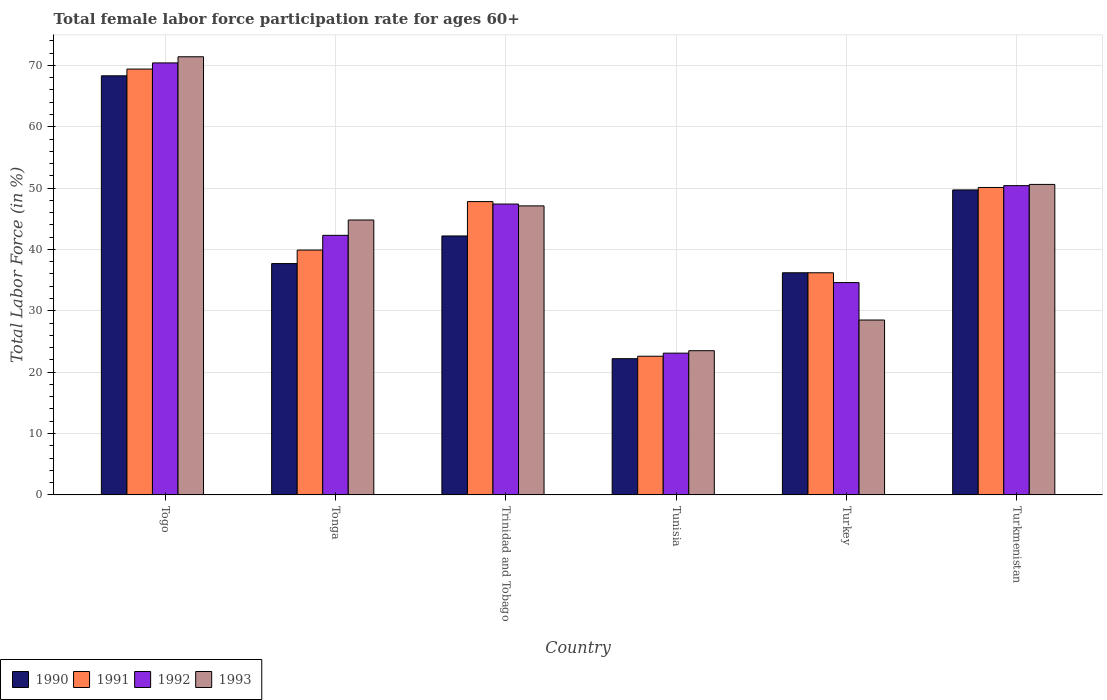How many different coloured bars are there?
Your response must be concise. 4. Are the number of bars per tick equal to the number of legend labels?
Give a very brief answer. Yes. How many bars are there on the 3rd tick from the right?
Give a very brief answer. 4. What is the label of the 3rd group of bars from the left?
Provide a short and direct response. Trinidad and Tobago. In how many cases, is the number of bars for a given country not equal to the number of legend labels?
Offer a terse response. 0. Across all countries, what is the maximum female labor force participation rate in 1990?
Offer a terse response. 68.3. Across all countries, what is the minimum female labor force participation rate in 1992?
Offer a very short reply. 23.1. In which country was the female labor force participation rate in 1991 maximum?
Ensure brevity in your answer.  Togo. In which country was the female labor force participation rate in 1990 minimum?
Keep it short and to the point. Tunisia. What is the total female labor force participation rate in 1990 in the graph?
Your response must be concise. 256.3. What is the difference between the female labor force participation rate in 1993 in Trinidad and Tobago and that in Turkey?
Keep it short and to the point. 18.6. What is the difference between the female labor force participation rate in 1990 in Turkmenistan and the female labor force participation rate in 1991 in Togo?
Your answer should be very brief. -19.7. What is the average female labor force participation rate in 1992 per country?
Your answer should be compact. 44.7. What is the difference between the female labor force participation rate of/in 1991 and female labor force participation rate of/in 1990 in Turkmenistan?
Your response must be concise. 0.4. What is the ratio of the female labor force participation rate in 1992 in Tonga to that in Turkmenistan?
Your answer should be very brief. 0.84. Is the female labor force participation rate in 1990 in Trinidad and Tobago less than that in Tunisia?
Keep it short and to the point. No. What is the difference between the highest and the lowest female labor force participation rate in 1992?
Your answer should be very brief. 47.3. In how many countries, is the female labor force participation rate in 1993 greater than the average female labor force participation rate in 1993 taken over all countries?
Your answer should be compact. 4. What does the 1st bar from the left in Tunisia represents?
Give a very brief answer. 1990. Is it the case that in every country, the sum of the female labor force participation rate in 1991 and female labor force participation rate in 1990 is greater than the female labor force participation rate in 1993?
Your answer should be very brief. Yes. Are all the bars in the graph horizontal?
Provide a succinct answer. No. How many countries are there in the graph?
Give a very brief answer. 6. Does the graph contain any zero values?
Keep it short and to the point. No. How are the legend labels stacked?
Provide a succinct answer. Horizontal. What is the title of the graph?
Give a very brief answer. Total female labor force participation rate for ages 60+. Does "1976" appear as one of the legend labels in the graph?
Keep it short and to the point. No. What is the label or title of the X-axis?
Offer a very short reply. Country. What is the Total Labor Force (in %) in 1990 in Togo?
Ensure brevity in your answer.  68.3. What is the Total Labor Force (in %) in 1991 in Togo?
Your answer should be compact. 69.4. What is the Total Labor Force (in %) of 1992 in Togo?
Your answer should be compact. 70.4. What is the Total Labor Force (in %) of 1993 in Togo?
Make the answer very short. 71.4. What is the Total Labor Force (in %) in 1990 in Tonga?
Make the answer very short. 37.7. What is the Total Labor Force (in %) in 1991 in Tonga?
Provide a short and direct response. 39.9. What is the Total Labor Force (in %) in 1992 in Tonga?
Offer a very short reply. 42.3. What is the Total Labor Force (in %) of 1993 in Tonga?
Offer a very short reply. 44.8. What is the Total Labor Force (in %) of 1990 in Trinidad and Tobago?
Give a very brief answer. 42.2. What is the Total Labor Force (in %) in 1991 in Trinidad and Tobago?
Offer a very short reply. 47.8. What is the Total Labor Force (in %) in 1992 in Trinidad and Tobago?
Give a very brief answer. 47.4. What is the Total Labor Force (in %) of 1993 in Trinidad and Tobago?
Your response must be concise. 47.1. What is the Total Labor Force (in %) of 1990 in Tunisia?
Give a very brief answer. 22.2. What is the Total Labor Force (in %) of 1991 in Tunisia?
Your answer should be very brief. 22.6. What is the Total Labor Force (in %) of 1992 in Tunisia?
Offer a terse response. 23.1. What is the Total Labor Force (in %) in 1993 in Tunisia?
Offer a terse response. 23.5. What is the Total Labor Force (in %) of 1990 in Turkey?
Keep it short and to the point. 36.2. What is the Total Labor Force (in %) of 1991 in Turkey?
Provide a short and direct response. 36.2. What is the Total Labor Force (in %) of 1992 in Turkey?
Keep it short and to the point. 34.6. What is the Total Labor Force (in %) of 1990 in Turkmenistan?
Your answer should be compact. 49.7. What is the Total Labor Force (in %) in 1991 in Turkmenistan?
Your answer should be compact. 50.1. What is the Total Labor Force (in %) in 1992 in Turkmenistan?
Your response must be concise. 50.4. What is the Total Labor Force (in %) of 1993 in Turkmenistan?
Offer a terse response. 50.6. Across all countries, what is the maximum Total Labor Force (in %) in 1990?
Make the answer very short. 68.3. Across all countries, what is the maximum Total Labor Force (in %) in 1991?
Your response must be concise. 69.4. Across all countries, what is the maximum Total Labor Force (in %) in 1992?
Provide a succinct answer. 70.4. Across all countries, what is the maximum Total Labor Force (in %) of 1993?
Keep it short and to the point. 71.4. Across all countries, what is the minimum Total Labor Force (in %) of 1990?
Your response must be concise. 22.2. Across all countries, what is the minimum Total Labor Force (in %) of 1991?
Give a very brief answer. 22.6. Across all countries, what is the minimum Total Labor Force (in %) in 1992?
Offer a terse response. 23.1. What is the total Total Labor Force (in %) of 1990 in the graph?
Your response must be concise. 256.3. What is the total Total Labor Force (in %) in 1991 in the graph?
Offer a very short reply. 266. What is the total Total Labor Force (in %) of 1992 in the graph?
Offer a very short reply. 268.2. What is the total Total Labor Force (in %) of 1993 in the graph?
Make the answer very short. 265.9. What is the difference between the Total Labor Force (in %) in 1990 in Togo and that in Tonga?
Offer a terse response. 30.6. What is the difference between the Total Labor Force (in %) in 1991 in Togo and that in Tonga?
Your answer should be very brief. 29.5. What is the difference between the Total Labor Force (in %) in 1992 in Togo and that in Tonga?
Keep it short and to the point. 28.1. What is the difference between the Total Labor Force (in %) in 1993 in Togo and that in Tonga?
Your answer should be compact. 26.6. What is the difference between the Total Labor Force (in %) in 1990 in Togo and that in Trinidad and Tobago?
Give a very brief answer. 26.1. What is the difference between the Total Labor Force (in %) of 1991 in Togo and that in Trinidad and Tobago?
Your answer should be compact. 21.6. What is the difference between the Total Labor Force (in %) of 1993 in Togo and that in Trinidad and Tobago?
Your answer should be very brief. 24.3. What is the difference between the Total Labor Force (in %) of 1990 in Togo and that in Tunisia?
Give a very brief answer. 46.1. What is the difference between the Total Labor Force (in %) in 1991 in Togo and that in Tunisia?
Offer a terse response. 46.8. What is the difference between the Total Labor Force (in %) of 1992 in Togo and that in Tunisia?
Provide a short and direct response. 47.3. What is the difference between the Total Labor Force (in %) in 1993 in Togo and that in Tunisia?
Make the answer very short. 47.9. What is the difference between the Total Labor Force (in %) of 1990 in Togo and that in Turkey?
Offer a terse response. 32.1. What is the difference between the Total Labor Force (in %) in 1991 in Togo and that in Turkey?
Provide a succinct answer. 33.2. What is the difference between the Total Labor Force (in %) of 1992 in Togo and that in Turkey?
Make the answer very short. 35.8. What is the difference between the Total Labor Force (in %) in 1993 in Togo and that in Turkey?
Your answer should be compact. 42.9. What is the difference between the Total Labor Force (in %) in 1991 in Togo and that in Turkmenistan?
Your answer should be very brief. 19.3. What is the difference between the Total Labor Force (in %) of 1993 in Togo and that in Turkmenistan?
Ensure brevity in your answer.  20.8. What is the difference between the Total Labor Force (in %) in 1991 in Tonga and that in Trinidad and Tobago?
Your response must be concise. -7.9. What is the difference between the Total Labor Force (in %) in 1991 in Tonga and that in Tunisia?
Ensure brevity in your answer.  17.3. What is the difference between the Total Labor Force (in %) of 1993 in Tonga and that in Tunisia?
Ensure brevity in your answer.  21.3. What is the difference between the Total Labor Force (in %) in 1990 in Tonga and that in Turkey?
Ensure brevity in your answer.  1.5. What is the difference between the Total Labor Force (in %) of 1991 in Tonga and that in Turkey?
Ensure brevity in your answer.  3.7. What is the difference between the Total Labor Force (in %) in 1993 in Tonga and that in Turkey?
Keep it short and to the point. 16.3. What is the difference between the Total Labor Force (in %) of 1990 in Tonga and that in Turkmenistan?
Your answer should be compact. -12. What is the difference between the Total Labor Force (in %) in 1991 in Tonga and that in Turkmenistan?
Provide a succinct answer. -10.2. What is the difference between the Total Labor Force (in %) of 1991 in Trinidad and Tobago and that in Tunisia?
Provide a succinct answer. 25.2. What is the difference between the Total Labor Force (in %) of 1992 in Trinidad and Tobago and that in Tunisia?
Provide a succinct answer. 24.3. What is the difference between the Total Labor Force (in %) of 1993 in Trinidad and Tobago and that in Tunisia?
Ensure brevity in your answer.  23.6. What is the difference between the Total Labor Force (in %) of 1990 in Trinidad and Tobago and that in Turkey?
Offer a terse response. 6. What is the difference between the Total Labor Force (in %) in 1991 in Trinidad and Tobago and that in Turkey?
Make the answer very short. 11.6. What is the difference between the Total Labor Force (in %) of 1992 in Trinidad and Tobago and that in Turkey?
Your response must be concise. 12.8. What is the difference between the Total Labor Force (in %) in 1991 in Trinidad and Tobago and that in Turkmenistan?
Offer a very short reply. -2.3. What is the difference between the Total Labor Force (in %) of 1991 in Tunisia and that in Turkey?
Make the answer very short. -13.6. What is the difference between the Total Labor Force (in %) of 1993 in Tunisia and that in Turkey?
Provide a short and direct response. -5. What is the difference between the Total Labor Force (in %) of 1990 in Tunisia and that in Turkmenistan?
Provide a short and direct response. -27.5. What is the difference between the Total Labor Force (in %) of 1991 in Tunisia and that in Turkmenistan?
Keep it short and to the point. -27.5. What is the difference between the Total Labor Force (in %) in 1992 in Tunisia and that in Turkmenistan?
Your answer should be compact. -27.3. What is the difference between the Total Labor Force (in %) of 1993 in Tunisia and that in Turkmenistan?
Make the answer very short. -27.1. What is the difference between the Total Labor Force (in %) of 1992 in Turkey and that in Turkmenistan?
Offer a very short reply. -15.8. What is the difference between the Total Labor Force (in %) in 1993 in Turkey and that in Turkmenistan?
Ensure brevity in your answer.  -22.1. What is the difference between the Total Labor Force (in %) of 1990 in Togo and the Total Labor Force (in %) of 1991 in Tonga?
Give a very brief answer. 28.4. What is the difference between the Total Labor Force (in %) in 1990 in Togo and the Total Labor Force (in %) in 1993 in Tonga?
Your answer should be very brief. 23.5. What is the difference between the Total Labor Force (in %) in 1991 in Togo and the Total Labor Force (in %) in 1992 in Tonga?
Give a very brief answer. 27.1. What is the difference between the Total Labor Force (in %) in 1991 in Togo and the Total Labor Force (in %) in 1993 in Tonga?
Keep it short and to the point. 24.6. What is the difference between the Total Labor Force (in %) of 1992 in Togo and the Total Labor Force (in %) of 1993 in Tonga?
Make the answer very short. 25.6. What is the difference between the Total Labor Force (in %) in 1990 in Togo and the Total Labor Force (in %) in 1991 in Trinidad and Tobago?
Provide a short and direct response. 20.5. What is the difference between the Total Labor Force (in %) in 1990 in Togo and the Total Labor Force (in %) in 1992 in Trinidad and Tobago?
Give a very brief answer. 20.9. What is the difference between the Total Labor Force (in %) of 1990 in Togo and the Total Labor Force (in %) of 1993 in Trinidad and Tobago?
Keep it short and to the point. 21.2. What is the difference between the Total Labor Force (in %) of 1991 in Togo and the Total Labor Force (in %) of 1992 in Trinidad and Tobago?
Your answer should be very brief. 22. What is the difference between the Total Labor Force (in %) of 1991 in Togo and the Total Labor Force (in %) of 1993 in Trinidad and Tobago?
Give a very brief answer. 22.3. What is the difference between the Total Labor Force (in %) of 1992 in Togo and the Total Labor Force (in %) of 1993 in Trinidad and Tobago?
Provide a succinct answer. 23.3. What is the difference between the Total Labor Force (in %) of 1990 in Togo and the Total Labor Force (in %) of 1991 in Tunisia?
Offer a very short reply. 45.7. What is the difference between the Total Labor Force (in %) in 1990 in Togo and the Total Labor Force (in %) in 1992 in Tunisia?
Ensure brevity in your answer.  45.2. What is the difference between the Total Labor Force (in %) of 1990 in Togo and the Total Labor Force (in %) of 1993 in Tunisia?
Keep it short and to the point. 44.8. What is the difference between the Total Labor Force (in %) of 1991 in Togo and the Total Labor Force (in %) of 1992 in Tunisia?
Provide a short and direct response. 46.3. What is the difference between the Total Labor Force (in %) in 1991 in Togo and the Total Labor Force (in %) in 1993 in Tunisia?
Provide a succinct answer. 45.9. What is the difference between the Total Labor Force (in %) of 1992 in Togo and the Total Labor Force (in %) of 1993 in Tunisia?
Provide a succinct answer. 46.9. What is the difference between the Total Labor Force (in %) in 1990 in Togo and the Total Labor Force (in %) in 1991 in Turkey?
Your response must be concise. 32.1. What is the difference between the Total Labor Force (in %) in 1990 in Togo and the Total Labor Force (in %) in 1992 in Turkey?
Provide a short and direct response. 33.7. What is the difference between the Total Labor Force (in %) in 1990 in Togo and the Total Labor Force (in %) in 1993 in Turkey?
Your response must be concise. 39.8. What is the difference between the Total Labor Force (in %) of 1991 in Togo and the Total Labor Force (in %) of 1992 in Turkey?
Offer a terse response. 34.8. What is the difference between the Total Labor Force (in %) of 1991 in Togo and the Total Labor Force (in %) of 1993 in Turkey?
Ensure brevity in your answer.  40.9. What is the difference between the Total Labor Force (in %) in 1992 in Togo and the Total Labor Force (in %) in 1993 in Turkey?
Offer a terse response. 41.9. What is the difference between the Total Labor Force (in %) in 1990 in Togo and the Total Labor Force (in %) in 1991 in Turkmenistan?
Provide a succinct answer. 18.2. What is the difference between the Total Labor Force (in %) of 1990 in Togo and the Total Labor Force (in %) of 1992 in Turkmenistan?
Offer a very short reply. 17.9. What is the difference between the Total Labor Force (in %) in 1992 in Togo and the Total Labor Force (in %) in 1993 in Turkmenistan?
Offer a very short reply. 19.8. What is the difference between the Total Labor Force (in %) of 1990 in Tonga and the Total Labor Force (in %) of 1993 in Trinidad and Tobago?
Offer a terse response. -9.4. What is the difference between the Total Labor Force (in %) of 1991 in Tonga and the Total Labor Force (in %) of 1992 in Trinidad and Tobago?
Make the answer very short. -7.5. What is the difference between the Total Labor Force (in %) of 1990 in Tonga and the Total Labor Force (in %) of 1991 in Tunisia?
Provide a short and direct response. 15.1. What is the difference between the Total Labor Force (in %) of 1990 in Tonga and the Total Labor Force (in %) of 1993 in Tunisia?
Offer a terse response. 14.2. What is the difference between the Total Labor Force (in %) of 1990 in Tonga and the Total Labor Force (in %) of 1992 in Turkey?
Offer a terse response. 3.1. What is the difference between the Total Labor Force (in %) of 1991 in Tonga and the Total Labor Force (in %) of 1993 in Turkmenistan?
Provide a succinct answer. -10.7. What is the difference between the Total Labor Force (in %) in 1990 in Trinidad and Tobago and the Total Labor Force (in %) in 1991 in Tunisia?
Give a very brief answer. 19.6. What is the difference between the Total Labor Force (in %) of 1990 in Trinidad and Tobago and the Total Labor Force (in %) of 1993 in Tunisia?
Offer a very short reply. 18.7. What is the difference between the Total Labor Force (in %) of 1991 in Trinidad and Tobago and the Total Labor Force (in %) of 1992 in Tunisia?
Ensure brevity in your answer.  24.7. What is the difference between the Total Labor Force (in %) of 1991 in Trinidad and Tobago and the Total Labor Force (in %) of 1993 in Tunisia?
Make the answer very short. 24.3. What is the difference between the Total Labor Force (in %) of 1992 in Trinidad and Tobago and the Total Labor Force (in %) of 1993 in Tunisia?
Your answer should be compact. 23.9. What is the difference between the Total Labor Force (in %) in 1990 in Trinidad and Tobago and the Total Labor Force (in %) in 1991 in Turkey?
Your answer should be compact. 6. What is the difference between the Total Labor Force (in %) in 1991 in Trinidad and Tobago and the Total Labor Force (in %) in 1992 in Turkey?
Your answer should be compact. 13.2. What is the difference between the Total Labor Force (in %) in 1991 in Trinidad and Tobago and the Total Labor Force (in %) in 1993 in Turkey?
Offer a terse response. 19.3. What is the difference between the Total Labor Force (in %) of 1992 in Trinidad and Tobago and the Total Labor Force (in %) of 1993 in Turkey?
Give a very brief answer. 18.9. What is the difference between the Total Labor Force (in %) in 1990 in Trinidad and Tobago and the Total Labor Force (in %) in 1991 in Turkmenistan?
Your answer should be very brief. -7.9. What is the difference between the Total Labor Force (in %) of 1990 in Trinidad and Tobago and the Total Labor Force (in %) of 1992 in Turkmenistan?
Ensure brevity in your answer.  -8.2. What is the difference between the Total Labor Force (in %) in 1991 in Trinidad and Tobago and the Total Labor Force (in %) in 1992 in Turkmenistan?
Make the answer very short. -2.6. What is the difference between the Total Labor Force (in %) of 1991 in Trinidad and Tobago and the Total Labor Force (in %) of 1993 in Turkmenistan?
Provide a succinct answer. -2.8. What is the difference between the Total Labor Force (in %) of 1991 in Tunisia and the Total Labor Force (in %) of 1993 in Turkey?
Offer a terse response. -5.9. What is the difference between the Total Labor Force (in %) of 1990 in Tunisia and the Total Labor Force (in %) of 1991 in Turkmenistan?
Provide a succinct answer. -27.9. What is the difference between the Total Labor Force (in %) in 1990 in Tunisia and the Total Labor Force (in %) in 1992 in Turkmenistan?
Keep it short and to the point. -28.2. What is the difference between the Total Labor Force (in %) of 1990 in Tunisia and the Total Labor Force (in %) of 1993 in Turkmenistan?
Give a very brief answer. -28.4. What is the difference between the Total Labor Force (in %) in 1991 in Tunisia and the Total Labor Force (in %) in 1992 in Turkmenistan?
Your response must be concise. -27.8. What is the difference between the Total Labor Force (in %) in 1992 in Tunisia and the Total Labor Force (in %) in 1993 in Turkmenistan?
Your answer should be very brief. -27.5. What is the difference between the Total Labor Force (in %) of 1990 in Turkey and the Total Labor Force (in %) of 1991 in Turkmenistan?
Offer a terse response. -13.9. What is the difference between the Total Labor Force (in %) of 1990 in Turkey and the Total Labor Force (in %) of 1992 in Turkmenistan?
Provide a short and direct response. -14.2. What is the difference between the Total Labor Force (in %) of 1990 in Turkey and the Total Labor Force (in %) of 1993 in Turkmenistan?
Give a very brief answer. -14.4. What is the difference between the Total Labor Force (in %) in 1991 in Turkey and the Total Labor Force (in %) in 1993 in Turkmenistan?
Offer a very short reply. -14.4. What is the difference between the Total Labor Force (in %) in 1992 in Turkey and the Total Labor Force (in %) in 1993 in Turkmenistan?
Offer a terse response. -16. What is the average Total Labor Force (in %) in 1990 per country?
Keep it short and to the point. 42.72. What is the average Total Labor Force (in %) in 1991 per country?
Your answer should be compact. 44.33. What is the average Total Labor Force (in %) in 1992 per country?
Provide a short and direct response. 44.7. What is the average Total Labor Force (in %) of 1993 per country?
Make the answer very short. 44.32. What is the difference between the Total Labor Force (in %) in 1990 and Total Labor Force (in %) in 1993 in Togo?
Offer a very short reply. -3.1. What is the difference between the Total Labor Force (in %) in 1992 and Total Labor Force (in %) in 1993 in Togo?
Offer a terse response. -1. What is the difference between the Total Labor Force (in %) in 1990 and Total Labor Force (in %) in 1991 in Tonga?
Your response must be concise. -2.2. What is the difference between the Total Labor Force (in %) of 1990 and Total Labor Force (in %) of 1992 in Tonga?
Provide a short and direct response. -4.6. What is the difference between the Total Labor Force (in %) in 1991 and Total Labor Force (in %) in 1993 in Trinidad and Tobago?
Your answer should be very brief. 0.7. What is the difference between the Total Labor Force (in %) of 1992 and Total Labor Force (in %) of 1993 in Trinidad and Tobago?
Your answer should be compact. 0.3. What is the difference between the Total Labor Force (in %) of 1990 and Total Labor Force (in %) of 1991 in Tunisia?
Keep it short and to the point. -0.4. What is the difference between the Total Labor Force (in %) in 1990 and Total Labor Force (in %) in 1992 in Tunisia?
Provide a succinct answer. -0.9. What is the difference between the Total Labor Force (in %) of 1991 and Total Labor Force (in %) of 1992 in Tunisia?
Your answer should be compact. -0.5. What is the difference between the Total Labor Force (in %) in 1992 and Total Labor Force (in %) in 1993 in Tunisia?
Provide a short and direct response. -0.4. What is the difference between the Total Labor Force (in %) in 1992 and Total Labor Force (in %) in 1993 in Turkey?
Give a very brief answer. 6.1. What is the difference between the Total Labor Force (in %) in 1990 and Total Labor Force (in %) in 1991 in Turkmenistan?
Your answer should be compact. -0.4. What is the difference between the Total Labor Force (in %) of 1990 and Total Labor Force (in %) of 1993 in Turkmenistan?
Your response must be concise. -0.9. What is the difference between the Total Labor Force (in %) in 1992 and Total Labor Force (in %) in 1993 in Turkmenistan?
Provide a short and direct response. -0.2. What is the ratio of the Total Labor Force (in %) of 1990 in Togo to that in Tonga?
Your answer should be very brief. 1.81. What is the ratio of the Total Labor Force (in %) of 1991 in Togo to that in Tonga?
Provide a short and direct response. 1.74. What is the ratio of the Total Labor Force (in %) of 1992 in Togo to that in Tonga?
Ensure brevity in your answer.  1.66. What is the ratio of the Total Labor Force (in %) of 1993 in Togo to that in Tonga?
Your response must be concise. 1.59. What is the ratio of the Total Labor Force (in %) of 1990 in Togo to that in Trinidad and Tobago?
Your response must be concise. 1.62. What is the ratio of the Total Labor Force (in %) of 1991 in Togo to that in Trinidad and Tobago?
Give a very brief answer. 1.45. What is the ratio of the Total Labor Force (in %) of 1992 in Togo to that in Trinidad and Tobago?
Make the answer very short. 1.49. What is the ratio of the Total Labor Force (in %) in 1993 in Togo to that in Trinidad and Tobago?
Your answer should be compact. 1.52. What is the ratio of the Total Labor Force (in %) of 1990 in Togo to that in Tunisia?
Your answer should be compact. 3.08. What is the ratio of the Total Labor Force (in %) of 1991 in Togo to that in Tunisia?
Offer a very short reply. 3.07. What is the ratio of the Total Labor Force (in %) of 1992 in Togo to that in Tunisia?
Give a very brief answer. 3.05. What is the ratio of the Total Labor Force (in %) of 1993 in Togo to that in Tunisia?
Make the answer very short. 3.04. What is the ratio of the Total Labor Force (in %) in 1990 in Togo to that in Turkey?
Your answer should be very brief. 1.89. What is the ratio of the Total Labor Force (in %) of 1991 in Togo to that in Turkey?
Give a very brief answer. 1.92. What is the ratio of the Total Labor Force (in %) in 1992 in Togo to that in Turkey?
Provide a succinct answer. 2.03. What is the ratio of the Total Labor Force (in %) in 1993 in Togo to that in Turkey?
Offer a terse response. 2.51. What is the ratio of the Total Labor Force (in %) in 1990 in Togo to that in Turkmenistan?
Offer a terse response. 1.37. What is the ratio of the Total Labor Force (in %) in 1991 in Togo to that in Turkmenistan?
Your answer should be very brief. 1.39. What is the ratio of the Total Labor Force (in %) of 1992 in Togo to that in Turkmenistan?
Provide a succinct answer. 1.4. What is the ratio of the Total Labor Force (in %) in 1993 in Togo to that in Turkmenistan?
Ensure brevity in your answer.  1.41. What is the ratio of the Total Labor Force (in %) in 1990 in Tonga to that in Trinidad and Tobago?
Offer a very short reply. 0.89. What is the ratio of the Total Labor Force (in %) in 1991 in Tonga to that in Trinidad and Tobago?
Offer a terse response. 0.83. What is the ratio of the Total Labor Force (in %) in 1992 in Tonga to that in Trinidad and Tobago?
Ensure brevity in your answer.  0.89. What is the ratio of the Total Labor Force (in %) of 1993 in Tonga to that in Trinidad and Tobago?
Your response must be concise. 0.95. What is the ratio of the Total Labor Force (in %) in 1990 in Tonga to that in Tunisia?
Provide a short and direct response. 1.7. What is the ratio of the Total Labor Force (in %) of 1991 in Tonga to that in Tunisia?
Offer a very short reply. 1.77. What is the ratio of the Total Labor Force (in %) of 1992 in Tonga to that in Tunisia?
Your answer should be very brief. 1.83. What is the ratio of the Total Labor Force (in %) in 1993 in Tonga to that in Tunisia?
Ensure brevity in your answer.  1.91. What is the ratio of the Total Labor Force (in %) of 1990 in Tonga to that in Turkey?
Provide a succinct answer. 1.04. What is the ratio of the Total Labor Force (in %) of 1991 in Tonga to that in Turkey?
Give a very brief answer. 1.1. What is the ratio of the Total Labor Force (in %) in 1992 in Tonga to that in Turkey?
Your answer should be very brief. 1.22. What is the ratio of the Total Labor Force (in %) in 1993 in Tonga to that in Turkey?
Make the answer very short. 1.57. What is the ratio of the Total Labor Force (in %) of 1990 in Tonga to that in Turkmenistan?
Offer a very short reply. 0.76. What is the ratio of the Total Labor Force (in %) of 1991 in Tonga to that in Turkmenistan?
Your response must be concise. 0.8. What is the ratio of the Total Labor Force (in %) in 1992 in Tonga to that in Turkmenistan?
Keep it short and to the point. 0.84. What is the ratio of the Total Labor Force (in %) of 1993 in Tonga to that in Turkmenistan?
Your response must be concise. 0.89. What is the ratio of the Total Labor Force (in %) of 1990 in Trinidad and Tobago to that in Tunisia?
Provide a succinct answer. 1.9. What is the ratio of the Total Labor Force (in %) of 1991 in Trinidad and Tobago to that in Tunisia?
Give a very brief answer. 2.12. What is the ratio of the Total Labor Force (in %) of 1992 in Trinidad and Tobago to that in Tunisia?
Provide a short and direct response. 2.05. What is the ratio of the Total Labor Force (in %) in 1993 in Trinidad and Tobago to that in Tunisia?
Your answer should be compact. 2. What is the ratio of the Total Labor Force (in %) of 1990 in Trinidad and Tobago to that in Turkey?
Your response must be concise. 1.17. What is the ratio of the Total Labor Force (in %) of 1991 in Trinidad and Tobago to that in Turkey?
Make the answer very short. 1.32. What is the ratio of the Total Labor Force (in %) of 1992 in Trinidad and Tobago to that in Turkey?
Give a very brief answer. 1.37. What is the ratio of the Total Labor Force (in %) of 1993 in Trinidad and Tobago to that in Turkey?
Ensure brevity in your answer.  1.65. What is the ratio of the Total Labor Force (in %) in 1990 in Trinidad and Tobago to that in Turkmenistan?
Ensure brevity in your answer.  0.85. What is the ratio of the Total Labor Force (in %) of 1991 in Trinidad and Tobago to that in Turkmenistan?
Offer a very short reply. 0.95. What is the ratio of the Total Labor Force (in %) of 1992 in Trinidad and Tobago to that in Turkmenistan?
Your response must be concise. 0.94. What is the ratio of the Total Labor Force (in %) in 1993 in Trinidad and Tobago to that in Turkmenistan?
Give a very brief answer. 0.93. What is the ratio of the Total Labor Force (in %) of 1990 in Tunisia to that in Turkey?
Give a very brief answer. 0.61. What is the ratio of the Total Labor Force (in %) in 1991 in Tunisia to that in Turkey?
Give a very brief answer. 0.62. What is the ratio of the Total Labor Force (in %) of 1992 in Tunisia to that in Turkey?
Ensure brevity in your answer.  0.67. What is the ratio of the Total Labor Force (in %) of 1993 in Tunisia to that in Turkey?
Your answer should be very brief. 0.82. What is the ratio of the Total Labor Force (in %) in 1990 in Tunisia to that in Turkmenistan?
Provide a short and direct response. 0.45. What is the ratio of the Total Labor Force (in %) of 1991 in Tunisia to that in Turkmenistan?
Your response must be concise. 0.45. What is the ratio of the Total Labor Force (in %) in 1992 in Tunisia to that in Turkmenistan?
Offer a very short reply. 0.46. What is the ratio of the Total Labor Force (in %) in 1993 in Tunisia to that in Turkmenistan?
Provide a succinct answer. 0.46. What is the ratio of the Total Labor Force (in %) of 1990 in Turkey to that in Turkmenistan?
Provide a succinct answer. 0.73. What is the ratio of the Total Labor Force (in %) in 1991 in Turkey to that in Turkmenistan?
Offer a terse response. 0.72. What is the ratio of the Total Labor Force (in %) in 1992 in Turkey to that in Turkmenistan?
Provide a succinct answer. 0.69. What is the ratio of the Total Labor Force (in %) in 1993 in Turkey to that in Turkmenistan?
Offer a very short reply. 0.56. What is the difference between the highest and the second highest Total Labor Force (in %) of 1991?
Offer a very short reply. 19.3. What is the difference between the highest and the second highest Total Labor Force (in %) of 1993?
Make the answer very short. 20.8. What is the difference between the highest and the lowest Total Labor Force (in %) in 1990?
Your answer should be very brief. 46.1. What is the difference between the highest and the lowest Total Labor Force (in %) in 1991?
Make the answer very short. 46.8. What is the difference between the highest and the lowest Total Labor Force (in %) in 1992?
Offer a very short reply. 47.3. What is the difference between the highest and the lowest Total Labor Force (in %) of 1993?
Provide a short and direct response. 47.9. 